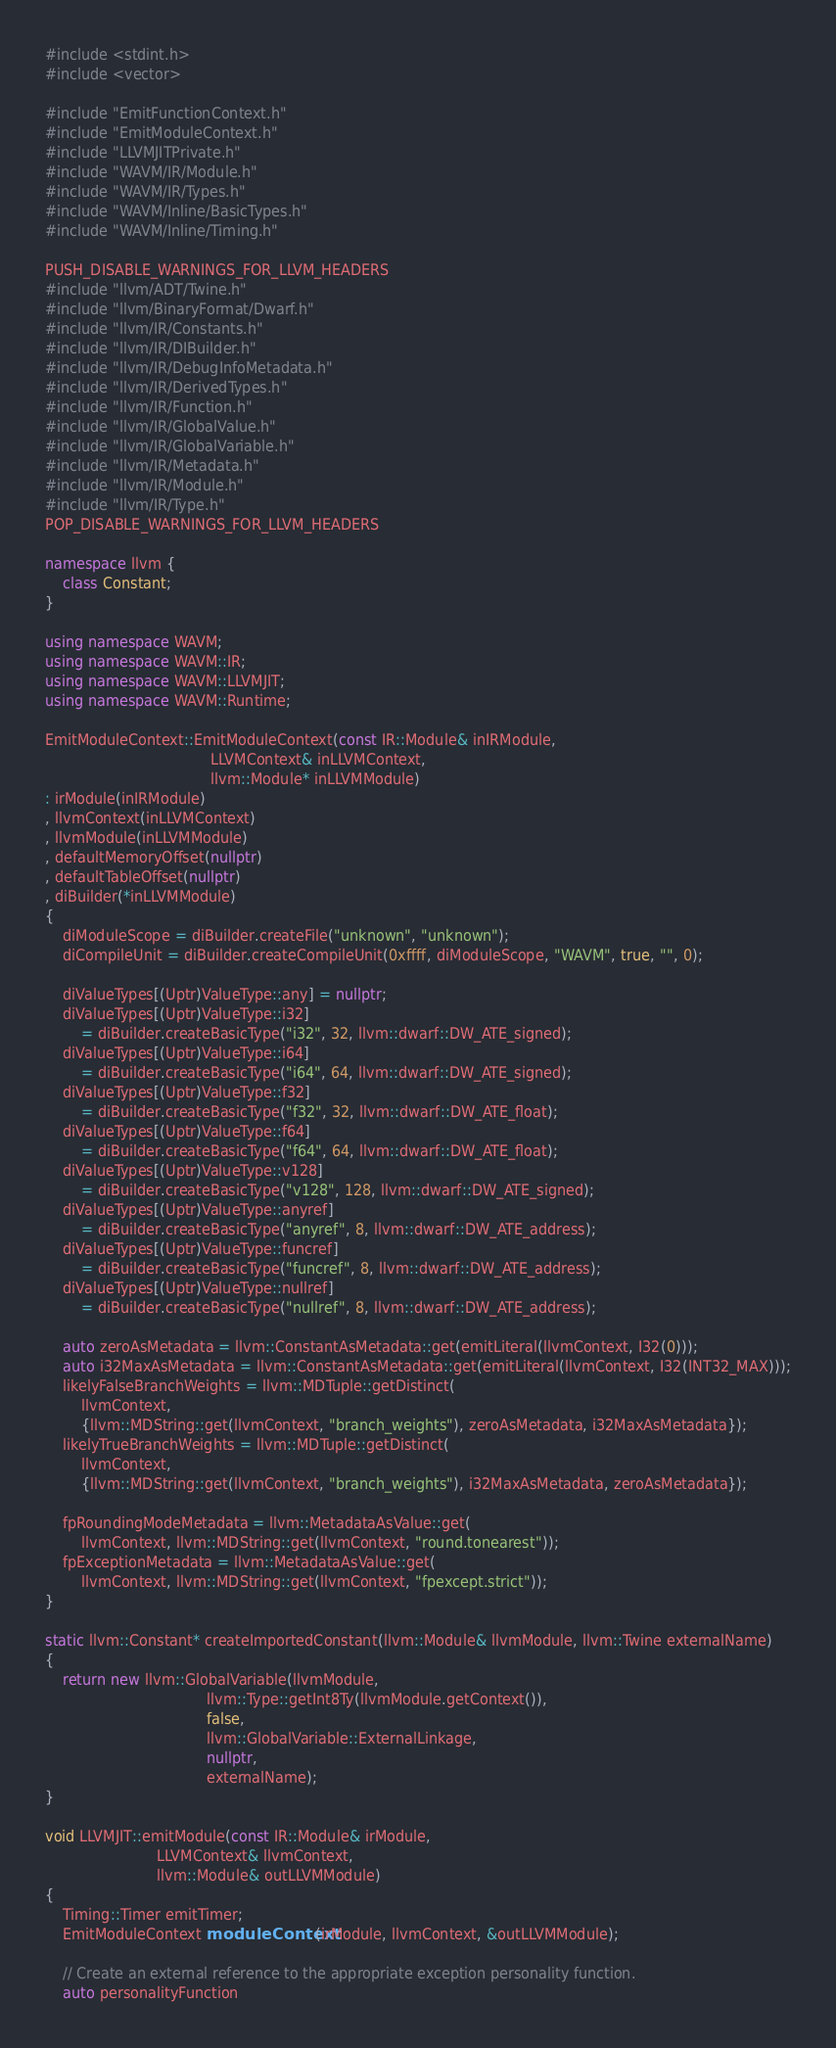<code> <loc_0><loc_0><loc_500><loc_500><_C++_>#include <stdint.h>
#include <vector>

#include "EmitFunctionContext.h"
#include "EmitModuleContext.h"
#include "LLVMJITPrivate.h"
#include "WAVM/IR/Module.h"
#include "WAVM/IR/Types.h"
#include "WAVM/Inline/BasicTypes.h"
#include "WAVM/Inline/Timing.h"

PUSH_DISABLE_WARNINGS_FOR_LLVM_HEADERS
#include "llvm/ADT/Twine.h"
#include "llvm/BinaryFormat/Dwarf.h"
#include "llvm/IR/Constants.h"
#include "llvm/IR/DIBuilder.h"
#include "llvm/IR/DebugInfoMetadata.h"
#include "llvm/IR/DerivedTypes.h"
#include "llvm/IR/Function.h"
#include "llvm/IR/GlobalValue.h"
#include "llvm/IR/GlobalVariable.h"
#include "llvm/IR/Metadata.h"
#include "llvm/IR/Module.h"
#include "llvm/IR/Type.h"
POP_DISABLE_WARNINGS_FOR_LLVM_HEADERS

namespace llvm {
	class Constant;
}

using namespace WAVM;
using namespace WAVM::IR;
using namespace WAVM::LLVMJIT;
using namespace WAVM::Runtime;

EmitModuleContext::EmitModuleContext(const IR::Module& inIRModule,
									 LLVMContext& inLLVMContext,
									 llvm::Module* inLLVMModule)
: irModule(inIRModule)
, llvmContext(inLLVMContext)
, llvmModule(inLLVMModule)
, defaultMemoryOffset(nullptr)
, defaultTableOffset(nullptr)
, diBuilder(*inLLVMModule)
{
	diModuleScope = diBuilder.createFile("unknown", "unknown");
	diCompileUnit = diBuilder.createCompileUnit(0xffff, diModuleScope, "WAVM", true, "", 0);

	diValueTypes[(Uptr)ValueType::any] = nullptr;
	diValueTypes[(Uptr)ValueType::i32]
		= diBuilder.createBasicType("i32", 32, llvm::dwarf::DW_ATE_signed);
	diValueTypes[(Uptr)ValueType::i64]
		= diBuilder.createBasicType("i64", 64, llvm::dwarf::DW_ATE_signed);
	diValueTypes[(Uptr)ValueType::f32]
		= diBuilder.createBasicType("f32", 32, llvm::dwarf::DW_ATE_float);
	diValueTypes[(Uptr)ValueType::f64]
		= diBuilder.createBasicType("f64", 64, llvm::dwarf::DW_ATE_float);
	diValueTypes[(Uptr)ValueType::v128]
		= diBuilder.createBasicType("v128", 128, llvm::dwarf::DW_ATE_signed);
	diValueTypes[(Uptr)ValueType::anyref]
		= diBuilder.createBasicType("anyref", 8, llvm::dwarf::DW_ATE_address);
	diValueTypes[(Uptr)ValueType::funcref]
		= diBuilder.createBasicType("funcref", 8, llvm::dwarf::DW_ATE_address);
	diValueTypes[(Uptr)ValueType::nullref]
		= diBuilder.createBasicType("nullref", 8, llvm::dwarf::DW_ATE_address);

	auto zeroAsMetadata = llvm::ConstantAsMetadata::get(emitLiteral(llvmContext, I32(0)));
	auto i32MaxAsMetadata = llvm::ConstantAsMetadata::get(emitLiteral(llvmContext, I32(INT32_MAX)));
	likelyFalseBranchWeights = llvm::MDTuple::getDistinct(
		llvmContext,
		{llvm::MDString::get(llvmContext, "branch_weights"), zeroAsMetadata, i32MaxAsMetadata});
	likelyTrueBranchWeights = llvm::MDTuple::getDistinct(
		llvmContext,
		{llvm::MDString::get(llvmContext, "branch_weights"), i32MaxAsMetadata, zeroAsMetadata});

	fpRoundingModeMetadata = llvm::MetadataAsValue::get(
		llvmContext, llvm::MDString::get(llvmContext, "round.tonearest"));
	fpExceptionMetadata = llvm::MetadataAsValue::get(
		llvmContext, llvm::MDString::get(llvmContext, "fpexcept.strict"));
}

static llvm::Constant* createImportedConstant(llvm::Module& llvmModule, llvm::Twine externalName)
{
	return new llvm::GlobalVariable(llvmModule,
									llvm::Type::getInt8Ty(llvmModule.getContext()),
									false,
									llvm::GlobalVariable::ExternalLinkage,
									nullptr,
									externalName);
}

void LLVMJIT::emitModule(const IR::Module& irModule,
						 LLVMContext& llvmContext,
						 llvm::Module& outLLVMModule)
{
	Timing::Timer emitTimer;
	EmitModuleContext moduleContext(irModule, llvmContext, &outLLVMModule);

	// Create an external reference to the appropriate exception personality function.
	auto personalityFunction</code> 